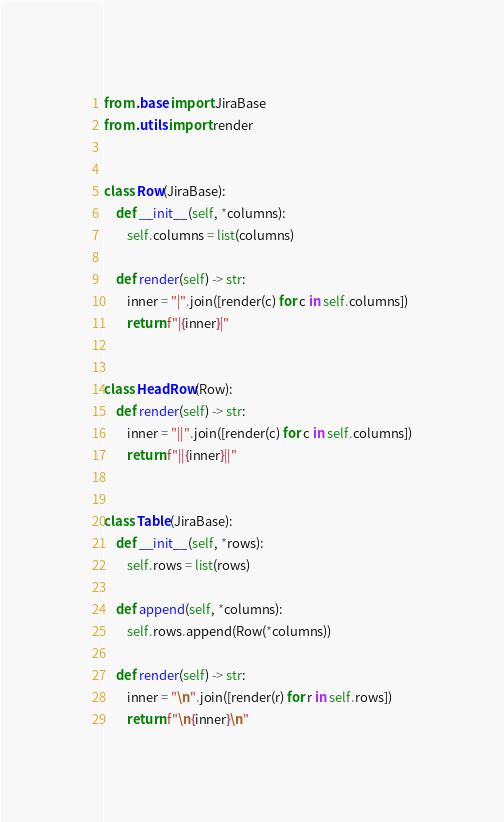Convert code to text. <code><loc_0><loc_0><loc_500><loc_500><_Python_>from .base import JiraBase
from .utils import render


class Row(JiraBase):
    def __init__(self, *columns):
        self.columns = list(columns)

    def render(self) -> str:
        inner = "|".join([render(c) for c in self.columns])
        return f"|{inner}|"


class HeadRow(Row):
    def render(self) -> str:
        inner = "||".join([render(c) for c in self.columns])
        return f"||{inner}||"


class Table(JiraBase):
    def __init__(self, *rows):
        self.rows = list(rows)

    def append(self, *columns):
        self.rows.append(Row(*columns))

    def render(self) -> str:
        inner = "\n".join([render(r) for r in self.rows])
        return f"\n{inner}\n"</code> 